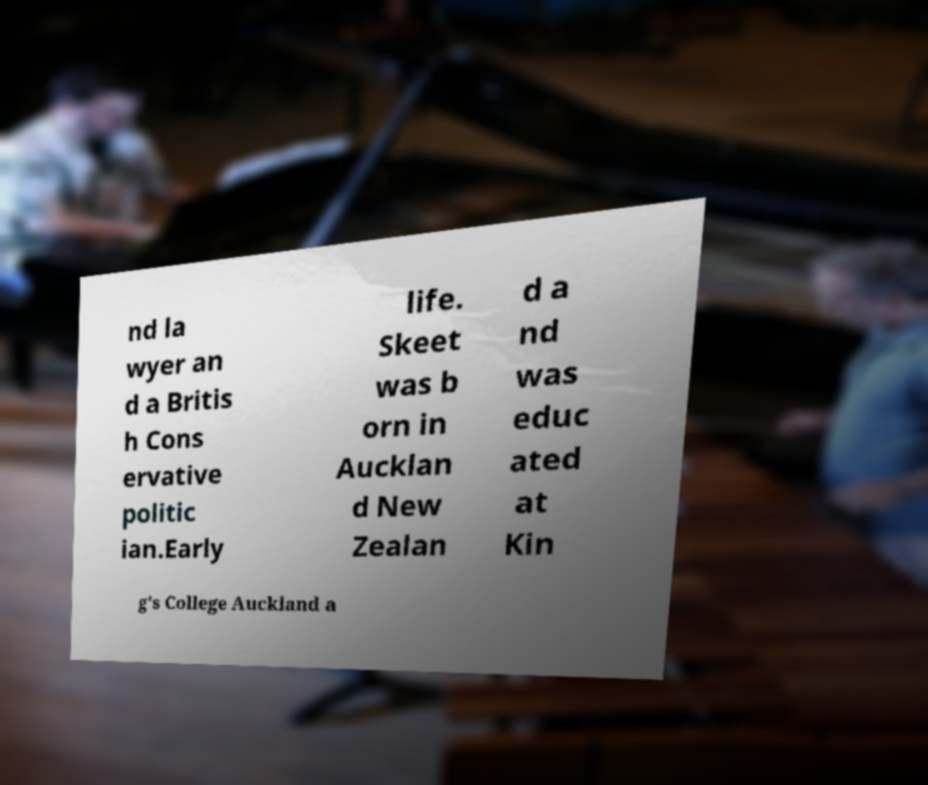Can you read and provide the text displayed in the image?This photo seems to have some interesting text. Can you extract and type it out for me? nd la wyer an d a Britis h Cons ervative politic ian.Early life. Skeet was b orn in Aucklan d New Zealan d a nd was educ ated at Kin g's College Auckland a 